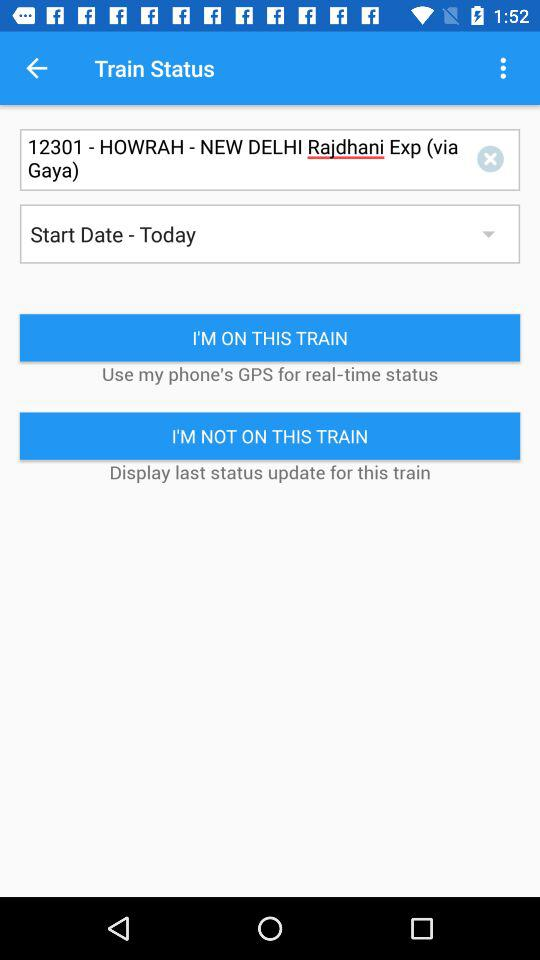What is the train status?
When the provided information is insufficient, respond with <no answer>. <no answer> 